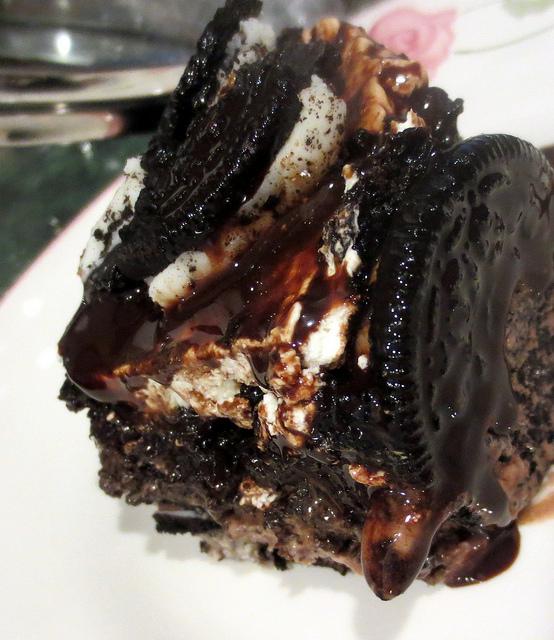Is this a cookie?
Short answer required. No. Is the food a dessert?
Concise answer only. Yes. What color is the plate?
Quick response, please. White. 